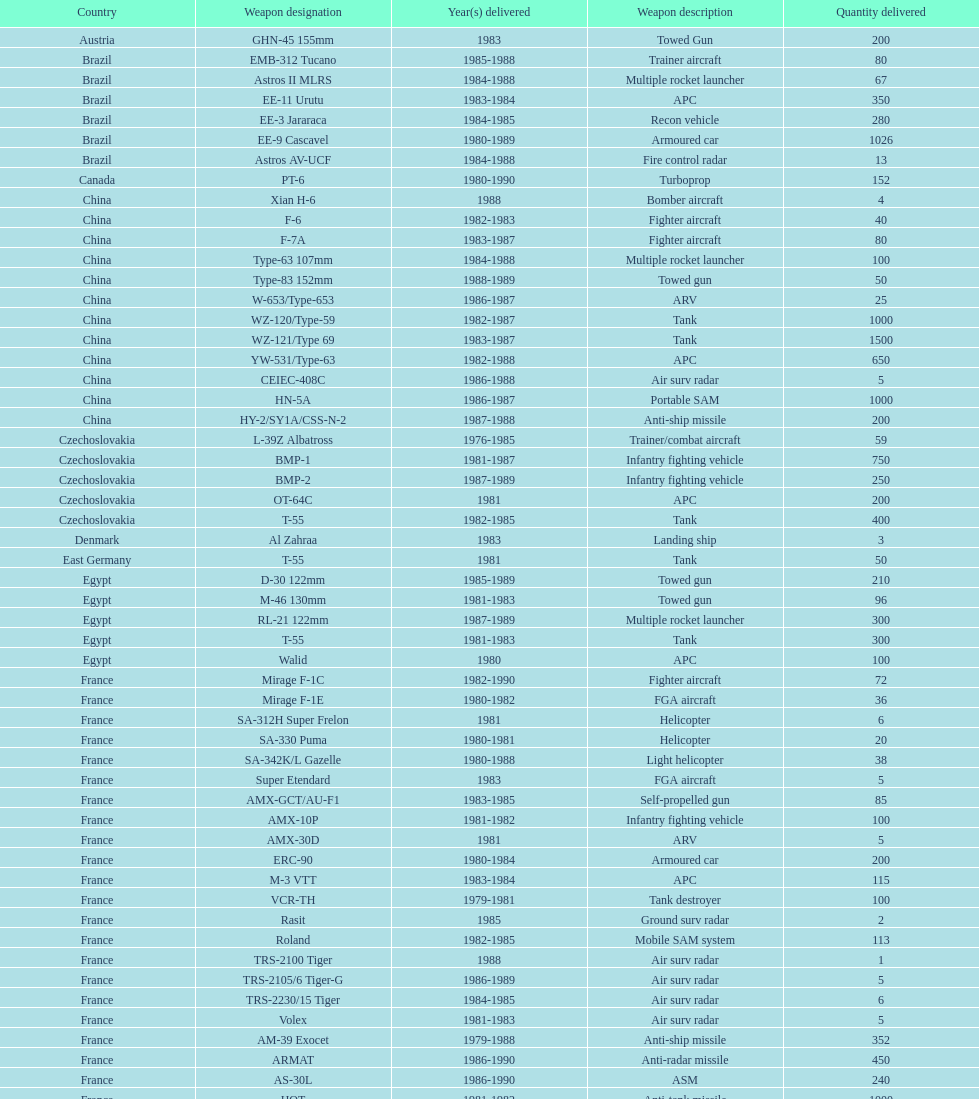What is the total number of tanks sold by china to iraq? 2500. 